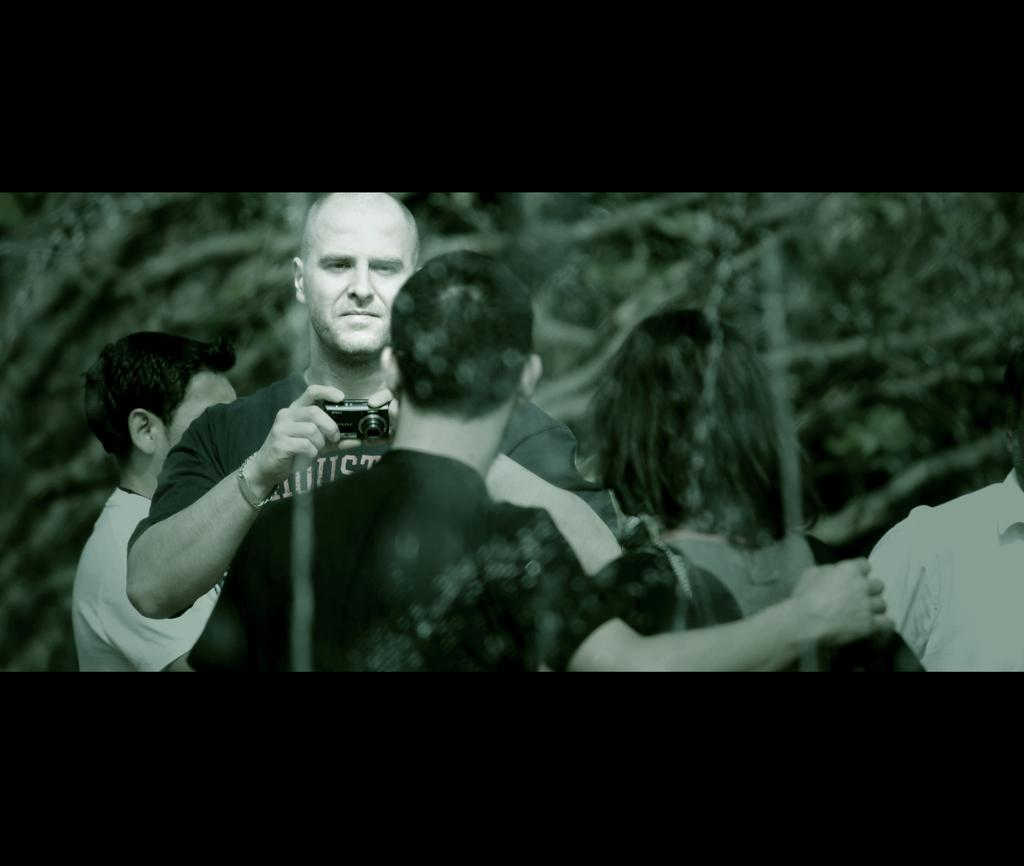How many people are in the image? There are four people in the image, two in the foreground and two in the background. What are the people in the foreground doing? One person in the foreground is holding a camera. What can be seen in the background of the image? There are trees visible in the background of the image. What type of pump is visible in the image? There is no pump present in the image. Can you describe the sponge used by the person in the background? There is no sponge visible in the image, and we cannot determine the actions of the people in the background based on the provided facts. 